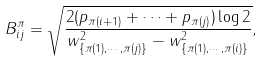Convert formula to latex. <formula><loc_0><loc_0><loc_500><loc_500>B _ { i j } ^ { \pi } = \sqrt { \frac { 2 ( p _ { \pi ( i + 1 ) } + \cdots + p _ { \pi ( j ) } ) \log 2 } { w ^ { 2 } _ { \{ \pi ( 1 ) , \cdots , \pi ( j ) \} } - w ^ { 2 } _ { \{ \pi ( 1 ) , \cdots , \pi ( i ) \} } } } ,</formula> 